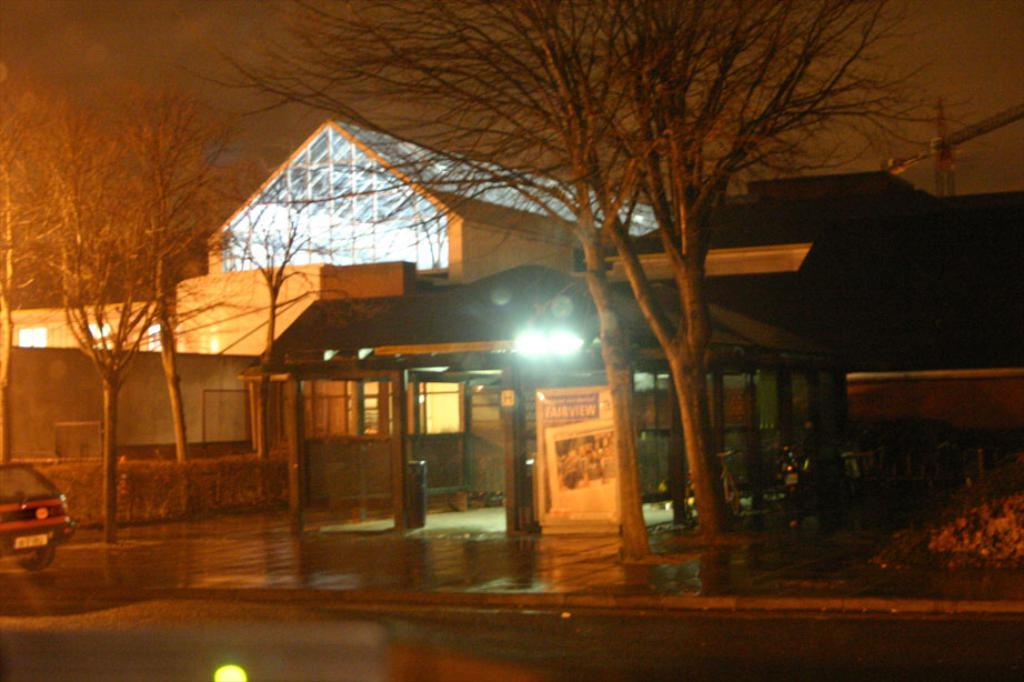What type of structures are present in the image? There are buildings in the image. What is located in front of the buildings? There is a board with text in front of the buildings. What type of vegetation is present in the image? There are trees in the image. What vehicle can be seen on the left side of the image? There is a car on the left side of the image. What is visible at the top of the image? The sky is visible at the top of the image. How many bikes are parked next to the car on the left side of the image? There are no bikes present in the image; only a car is visible on the left side. What type of body is depicted on the board with text in front of the buildings? There is no body depicted on the board with text in the image; it only contains text. 